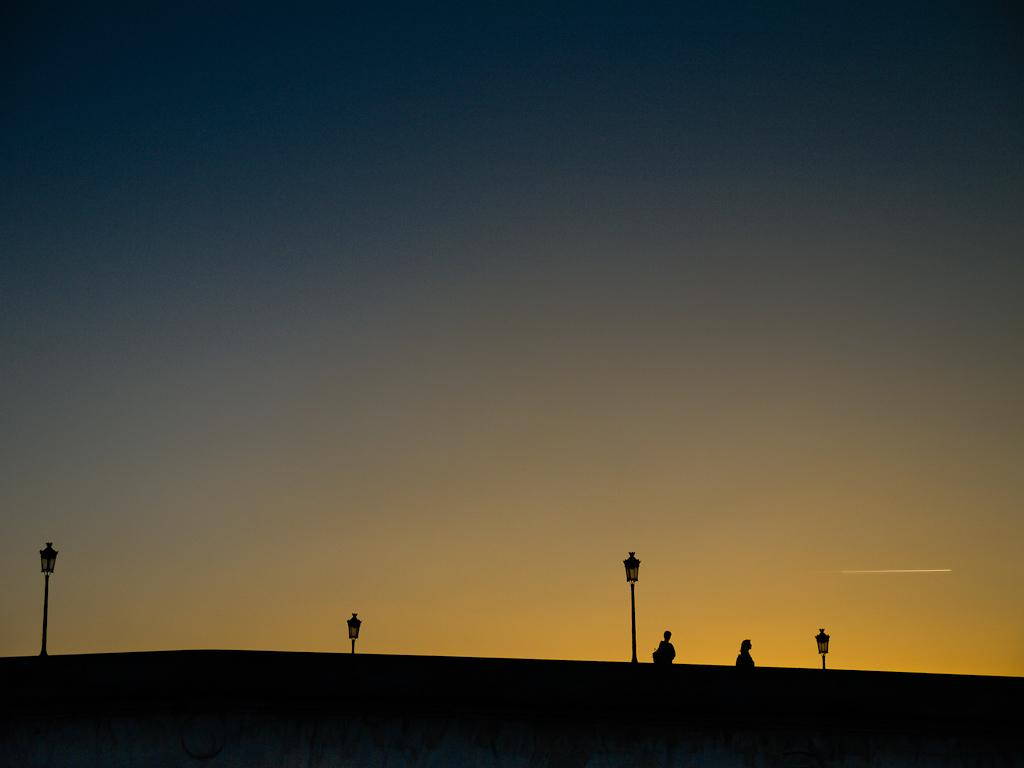What objects are present in the image that support something? There are poles in the image that support something. What is attached to the poles in the image? There are lights on the poles in the image. What are the two persons in the image doing? The two persons in the image are walking at the right side of the image. What is visible at the top of the image? The sky is visible at the top of the image. Where is the lunchroom located in the image? There is no mention of a lunchroom in the image. What design elements can be seen in the image? The image does not focus on design elements; it primarily features poles, lights, and people walking. 